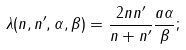Convert formula to latex. <formula><loc_0><loc_0><loc_500><loc_500>\lambda ( n , n ^ { \prime } , \alpha , \beta ) = \frac { 2 n n ^ { \prime } } { n + n ^ { \prime } } \frac { a \alpha } { \beta } ;</formula> 